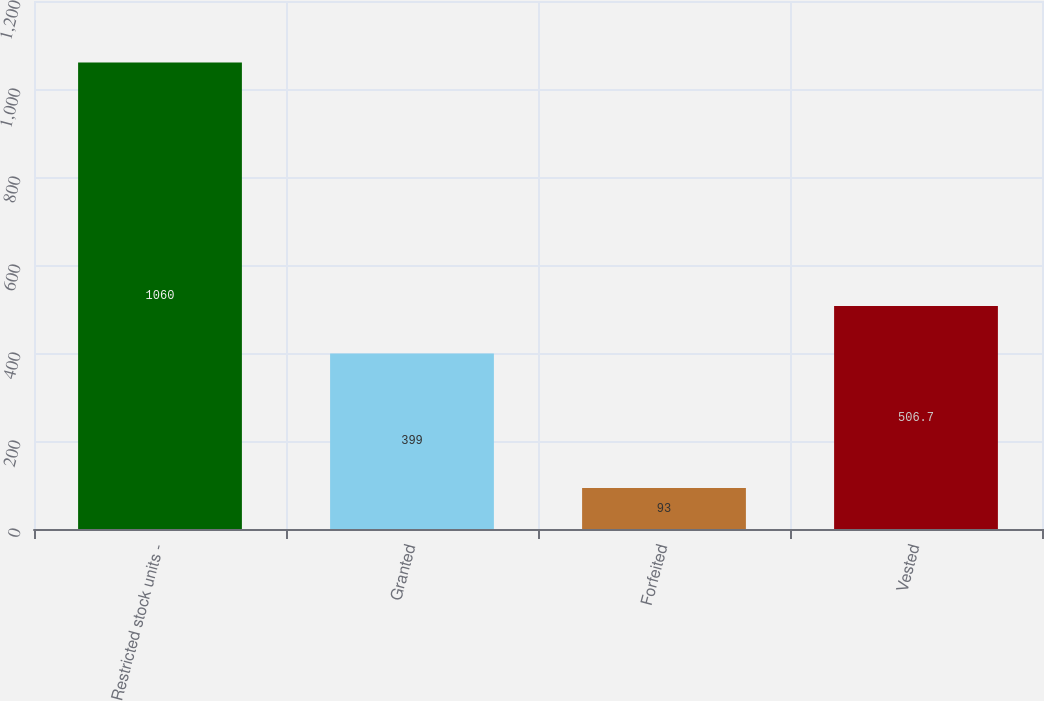<chart> <loc_0><loc_0><loc_500><loc_500><bar_chart><fcel>Restricted stock units -<fcel>Granted<fcel>Forfeited<fcel>Vested<nl><fcel>1060<fcel>399<fcel>93<fcel>506.7<nl></chart> 